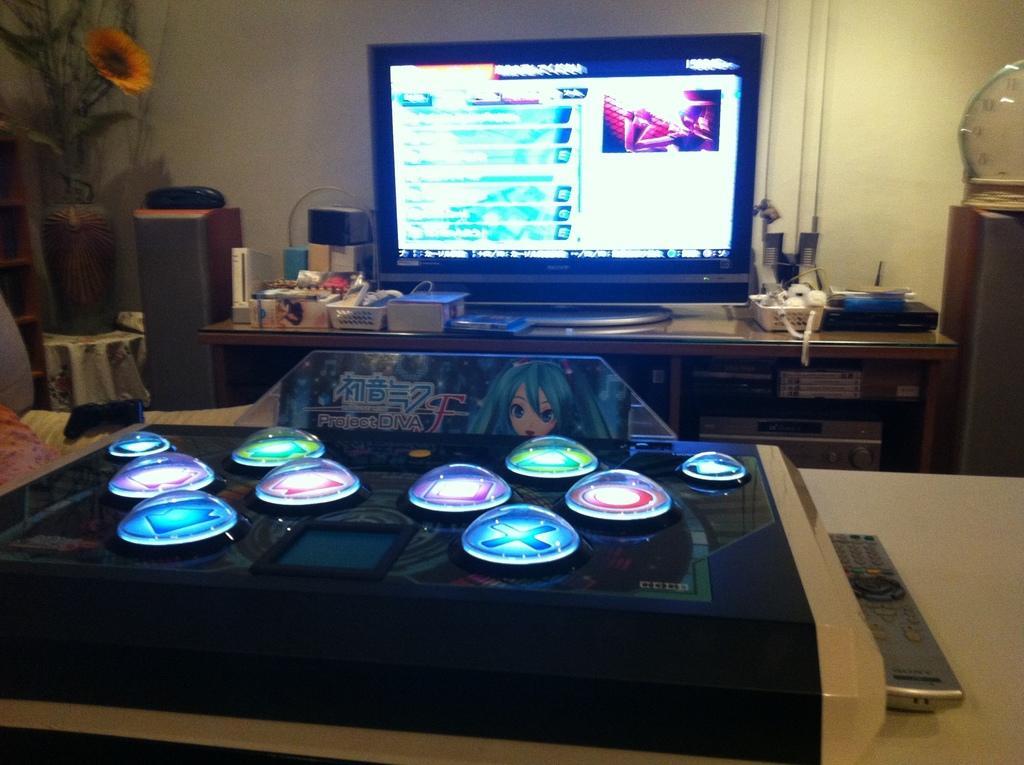In one or two sentences, can you explain what this image depicts? In this image there are tables and we can see a television, remotes and some objects placed on the tables. On the left there is a flower vase placed on the stand. In the background there is a wall. 